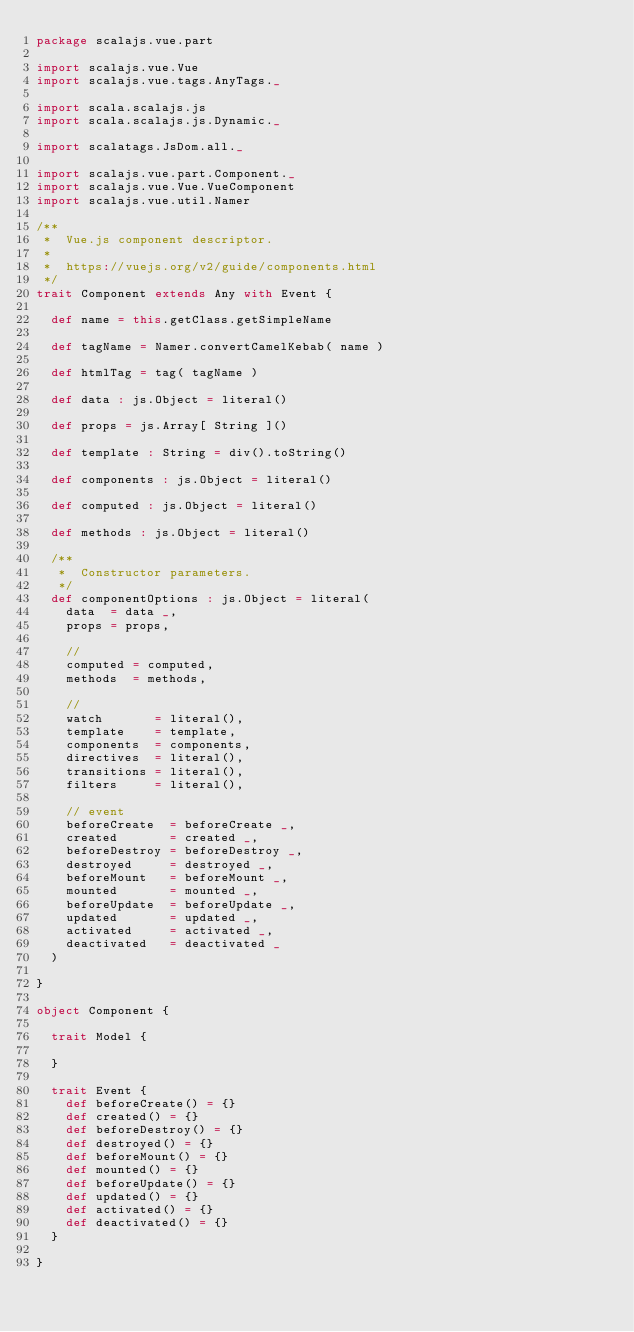Convert code to text. <code><loc_0><loc_0><loc_500><loc_500><_Scala_>package scalajs.vue.part

import scalajs.vue.Vue
import scalajs.vue.tags.AnyTags._

import scala.scalajs.js
import scala.scalajs.js.Dynamic._

import scalatags.JsDom.all._

import scalajs.vue.part.Component._
import scalajs.vue.Vue.VueComponent
import scalajs.vue.util.Namer

/**
 *  Vue.js component descriptor.
 *  
 *  https://vuejs.org/v2/guide/components.html
 */
trait Component extends Any with Event {

  def name = this.getClass.getSimpleName

  def tagName = Namer.convertCamelKebab( name )

  def htmlTag = tag( tagName )

  def data : js.Object = literal()

  def props = js.Array[ String ]()

  def template : String = div().toString()

  def components : js.Object = literal()

  def computed : js.Object = literal()

  def methods : js.Object = literal()

  /**
   *  Constructor parameters.
   */
  def componentOptions : js.Object = literal(
    data  = data _,
    props = props,

    //
    computed = computed,
    methods  = methods,

    //
    watch       = literal(),
    template    = template,
    components  = components,
    directives  = literal(),
    transitions = literal(),
    filters     = literal(),

    // event
    beforeCreate  = beforeCreate _,
    created       = created _,
    beforeDestroy = beforeDestroy _,
    destroyed     = destroyed _,
    beforeMount   = beforeMount _,
    mounted       = mounted _,
    beforeUpdate  = beforeUpdate _,
    updated       = updated _,
    activated     = activated _,
    deactivated   = deactivated _
  )

}

object Component {

  trait Model {

  }

  trait Event {
    def beforeCreate() = {}
    def created() = {}
    def beforeDestroy() = {}
    def destroyed() = {}
    def beforeMount() = {}
    def mounted() = {}
    def beforeUpdate() = {}
    def updated() = {}
    def activated() = {}
    def deactivated() = {}
  }

}
</code> 